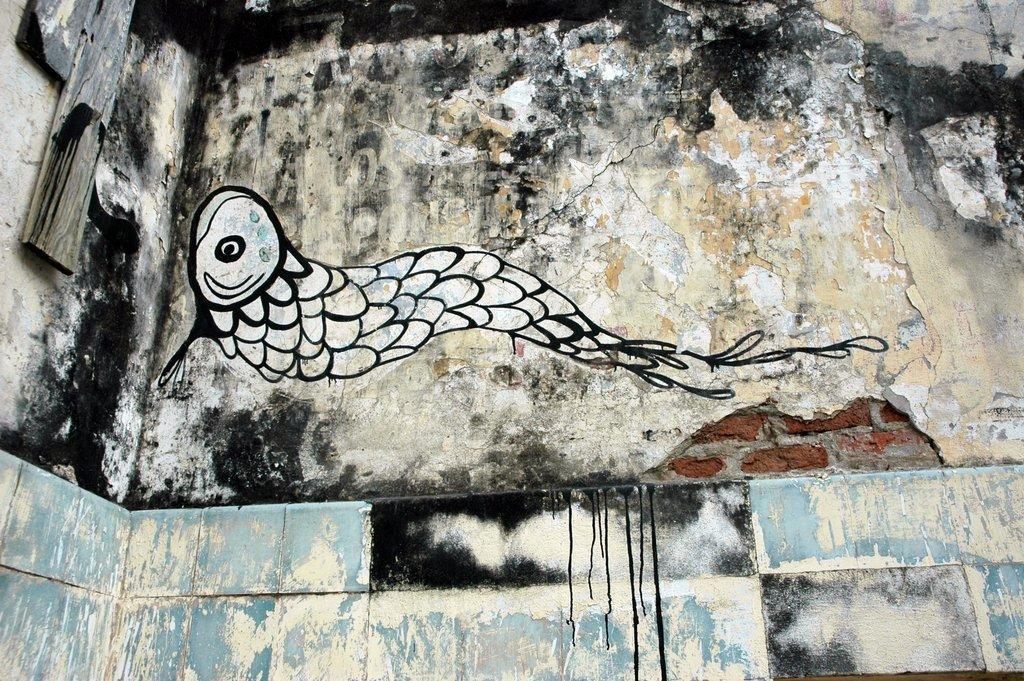Can you describe this image briefly? In this image we can see a wall with tiles and bricks. On the wall there is a drawing. On the right side we can see wooden pieces on the wall. 